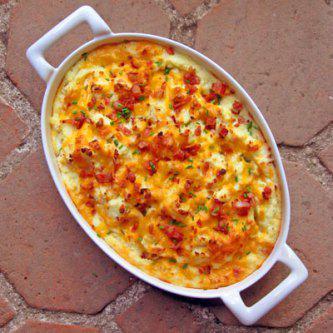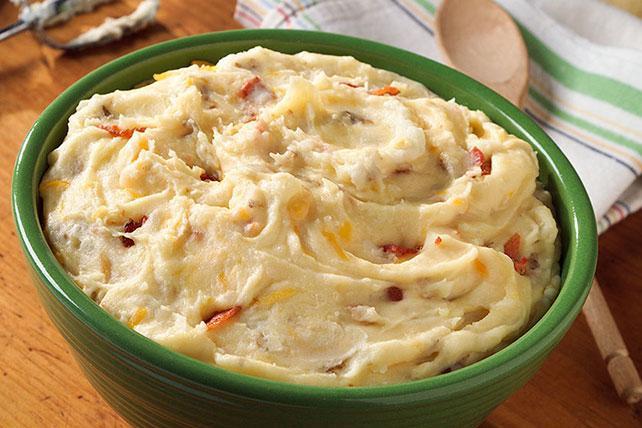The first image is the image on the left, the second image is the image on the right. Examine the images to the left and right. Is the description "One image in the pair has more than one plate or bowl." accurate? Answer yes or no. No. The first image is the image on the left, the second image is the image on the right. For the images shown, is this caption "At least one of the dishes has visible handles" true? Answer yes or no. Yes. 